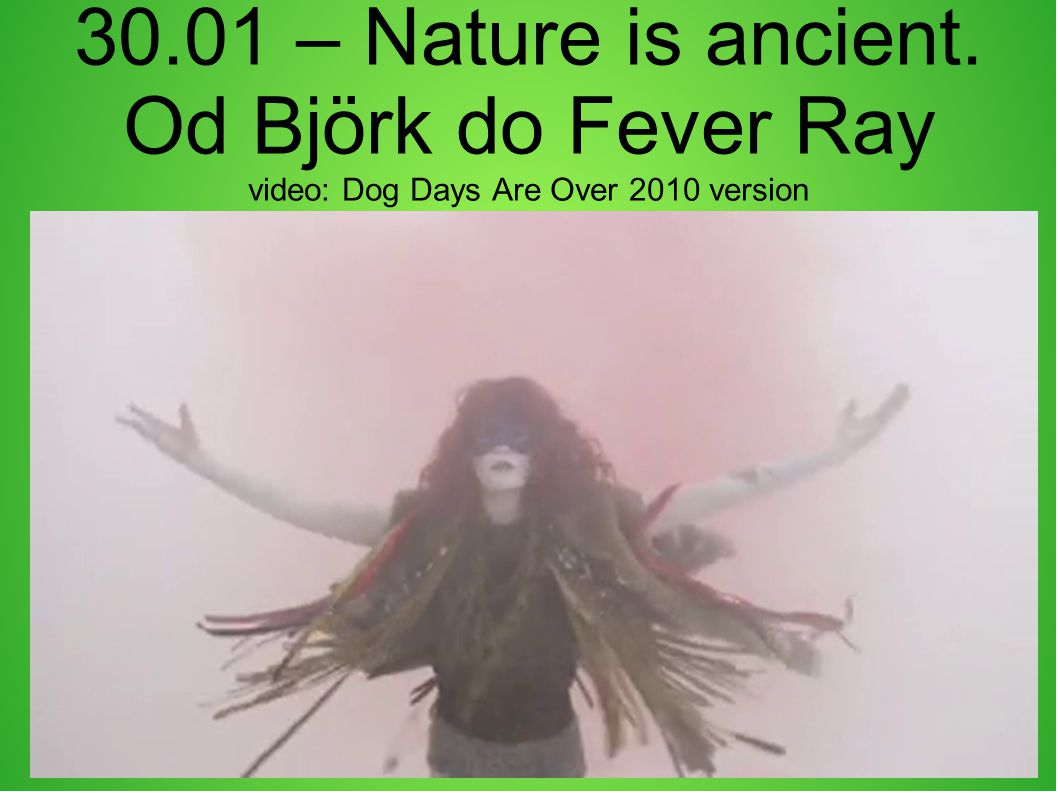Considering the text and the visual elements, what might be the relationship between the figure and the video mentioned? The relationship between the figure and the video appears to be one of an artist portrayed within their performance context. The attire and pose, combined with the obscured face, suggest a deliberate artistic or theatrical portrayal, likely within a music video or stage performance. The text presents the title 'Dog Days Are Over 2010 version,' suggesting that this image is a still from that specific video. The figure’s dramatic appearance likely serves to capture a central theme or emotion associated with the video, enhancing its narrative or aesthetic qualities. 